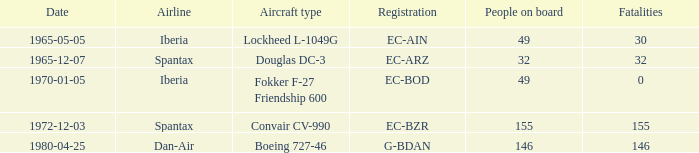How many fatalities are there for the airline of spantax, with a registration of ec-arz? 32.0. 